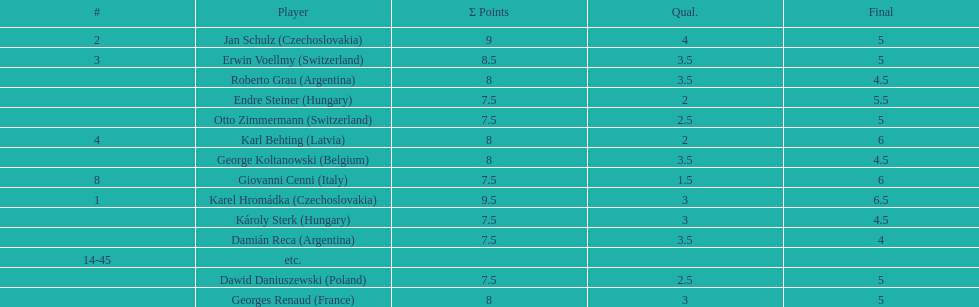Can you parse all the data within this table? {'header': ['#', 'Player', 'Σ Points', 'Qual.', 'Final'], 'rows': [['2', 'Jan Schulz\xa0(Czechoslovakia)', '9', '4', '5'], ['3', 'Erwin Voellmy\xa0(Switzerland)', '8.5', '3.5', '5'], ['', 'Roberto Grau\xa0(Argentina)', '8', '3.5', '4.5'], ['', 'Endre Steiner\xa0(Hungary)', '7.5', '2', '5.5'], ['', 'Otto Zimmermann\xa0(Switzerland)', '7.5', '2.5', '5'], ['4', 'Karl Behting\xa0(Latvia)', '8', '2', '6'], ['', 'George Koltanowski\xa0(Belgium)', '8', '3.5', '4.5'], ['8', 'Giovanni Cenni\xa0(Italy)', '7.5', '1.5', '6'], ['1', 'Karel Hromádka\xa0(Czechoslovakia)', '9.5', '3', '6.5'], ['', 'Károly Sterk\xa0(Hungary)', '7.5', '3', '4.5'], ['', 'Damián Reca\xa0(Argentina)', '7.5', '3.5', '4'], ['14-45', 'etc.', '', '', ''], ['', 'Dawid Daniuszewski\xa0(Poland)', '7.5', '2.5', '5'], ['', 'Georges Renaud\xa0(France)', '8', '3', '5']]} Karl behting and giovanni cenni each had final scores of what? 6. 